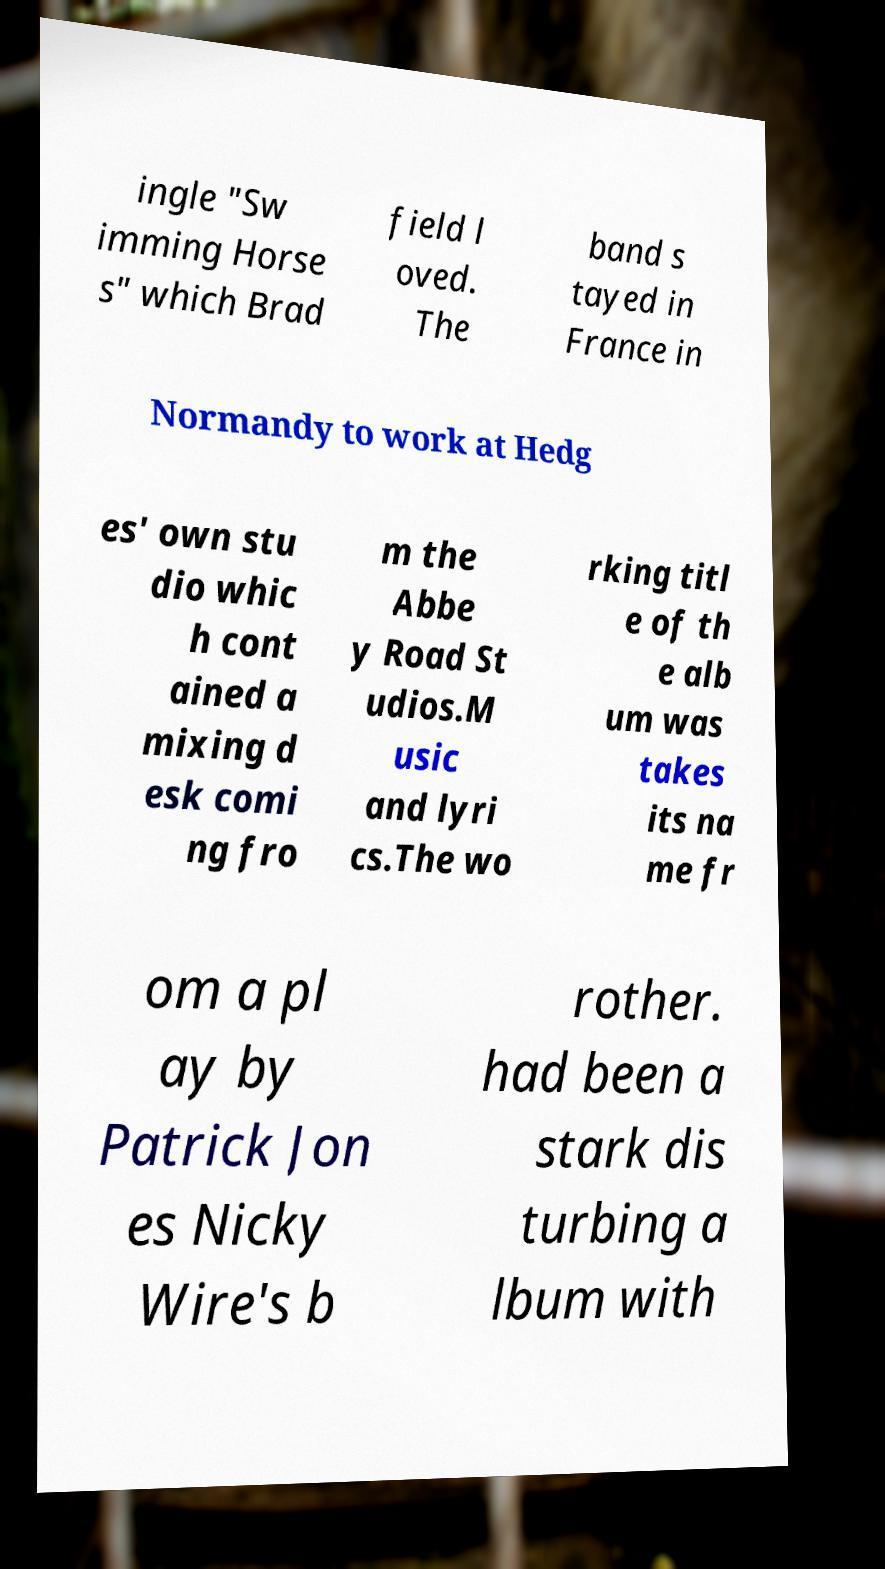Can you accurately transcribe the text from the provided image for me? ingle "Sw imming Horse s" which Brad field l oved. The band s tayed in France in Normandy to work at Hedg es' own stu dio whic h cont ained a mixing d esk comi ng fro m the Abbe y Road St udios.M usic and lyri cs.The wo rking titl e of th e alb um was takes its na me fr om a pl ay by Patrick Jon es Nicky Wire's b rother. had been a stark dis turbing a lbum with 